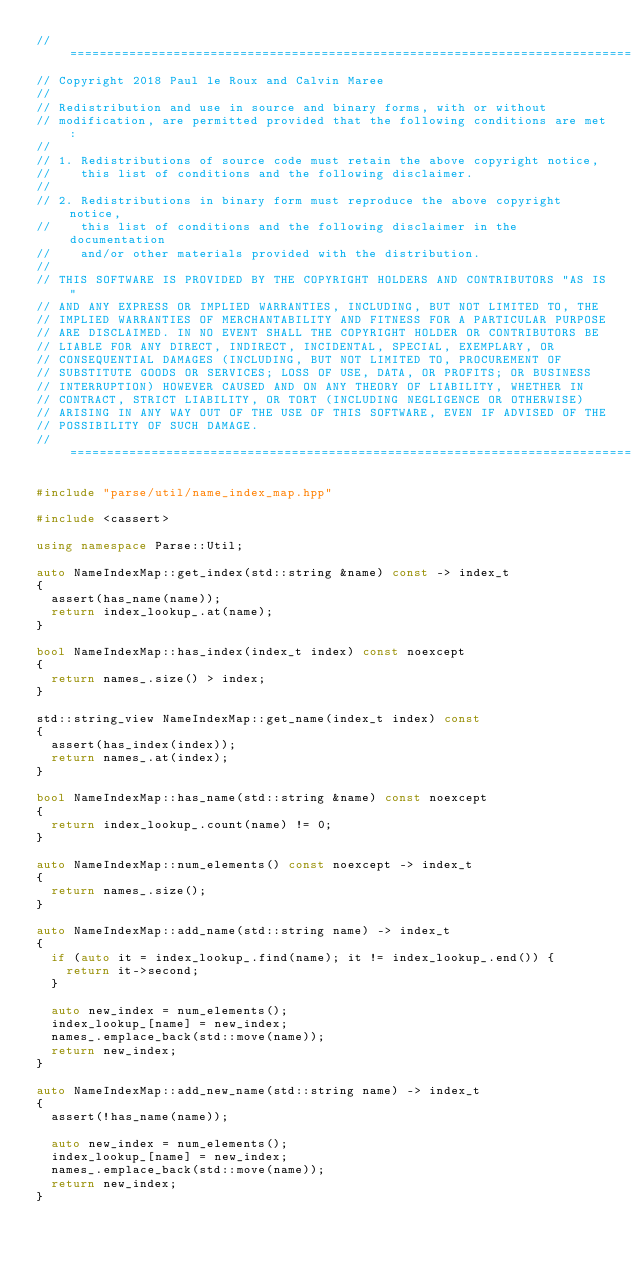<code> <loc_0><loc_0><loc_500><loc_500><_C++_>// ============================================================================
// Copyright 2018 Paul le Roux and Calvin Maree
//
// Redistribution and use in source and binary forms, with or without
// modification, are permitted provided that the following conditions are met:
//
// 1. Redistributions of source code must retain the above copyright notice,
//    this list of conditions and the following disclaimer.
//
// 2. Redistributions in binary form must reproduce the above copyright notice,
//    this list of conditions and the following disclaimer in the documentation
//    and/or other materials provided with the distribution.
//
// THIS SOFTWARE IS PROVIDED BY THE COPYRIGHT HOLDERS AND CONTRIBUTORS "AS IS"
// AND ANY EXPRESS OR IMPLIED WARRANTIES, INCLUDING, BUT NOT LIMITED TO, THE
// IMPLIED WARRANTIES OF MERCHANTABILITY AND FITNESS FOR A PARTICULAR PURPOSE
// ARE DISCLAIMED. IN NO EVENT SHALL THE COPYRIGHT HOLDER OR CONTRIBUTORS BE
// LIABLE FOR ANY DIRECT, INDIRECT, INCIDENTAL, SPECIAL, EXEMPLARY, OR
// CONSEQUENTIAL DAMAGES (INCLUDING, BUT NOT LIMITED TO, PROCUREMENT OF
// SUBSTITUTE GOODS OR SERVICES; LOSS OF USE, DATA, OR PROFITS; OR BUSINESS
// INTERRUPTION) HOWEVER CAUSED AND ON ANY THEORY OF LIABILITY, WHETHER IN
// CONTRACT, STRICT LIABILITY, OR TORT (INCLUDING NEGLIGENCE OR OTHERWISE)
// ARISING IN ANY WAY OUT OF THE USE OF THIS SOFTWARE, EVEN IF ADVISED OF THE
// POSSIBILITY OF SUCH DAMAGE.
// ============================================================================

#include "parse/util/name_index_map.hpp"

#include <cassert>

using namespace Parse::Util;

auto NameIndexMap::get_index(std::string &name) const -> index_t
{
  assert(has_name(name));
  return index_lookup_.at(name);
}

bool NameIndexMap::has_index(index_t index) const noexcept
{
  return names_.size() > index;
}

std::string_view NameIndexMap::get_name(index_t index) const
{
  assert(has_index(index));
  return names_.at(index);
}

bool NameIndexMap::has_name(std::string &name) const noexcept
{
  return index_lookup_.count(name) != 0;
}

auto NameIndexMap::num_elements() const noexcept -> index_t
{
  return names_.size();
}

auto NameIndexMap::add_name(std::string name) -> index_t
{
  if (auto it = index_lookup_.find(name); it != index_lookup_.end()) {
    return it->second;
  }

  auto new_index = num_elements();
  index_lookup_[name] = new_index;
  names_.emplace_back(std::move(name));
  return new_index;
}

auto NameIndexMap::add_new_name(std::string name) -> index_t
{
  assert(!has_name(name));

  auto new_index = num_elements();
  index_lookup_[name] = new_index;
  names_.emplace_back(std::move(name));
  return new_index;
}
</code> 